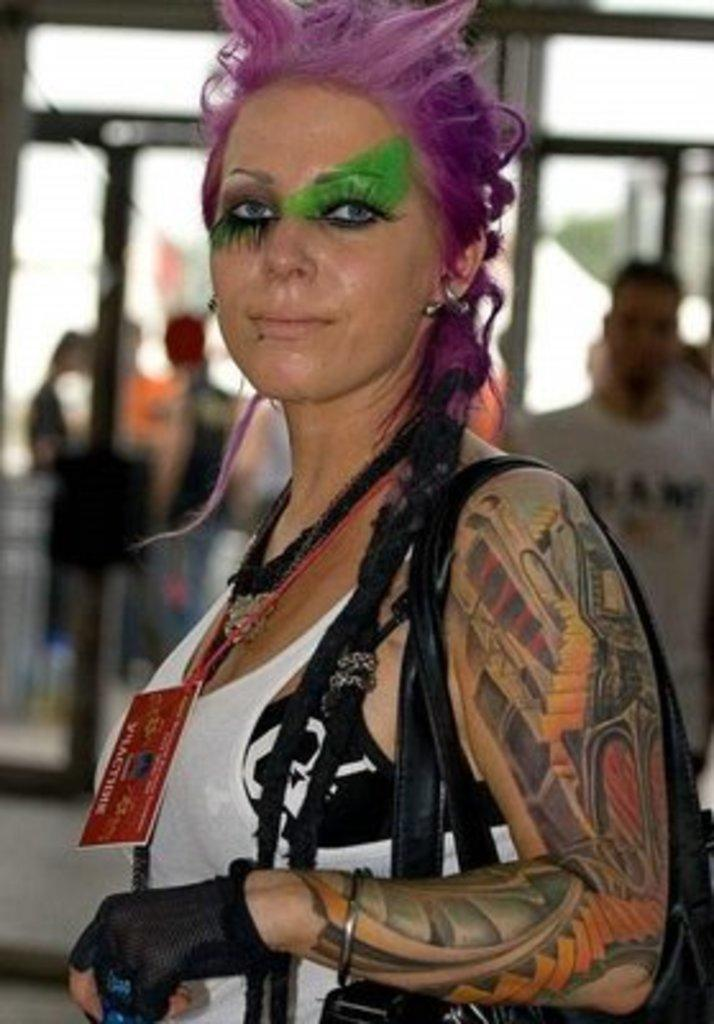What is the person in the image holding? The person is holding a card. Can you describe any additional features of the person? There is a tattoo on the person's hand. What can be seen in the background of the image? There are other people visible in the background, and they are wearing different color dresses. How would you describe the background of the image? The background is blurry. What type of game is the person playing in the image? There is no indication of a game being played in the image. The person is simply holding a card, and there is no context to suggest a game is in progress. 